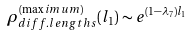<formula> <loc_0><loc_0><loc_500><loc_500>\rho _ { d i f f . l e n g t h s } ^ { ( \max i m u m ) } ( l _ { 1 } ) \sim e ^ { ( 1 - \lambda _ { 7 } ) l _ { 1 } }</formula> 